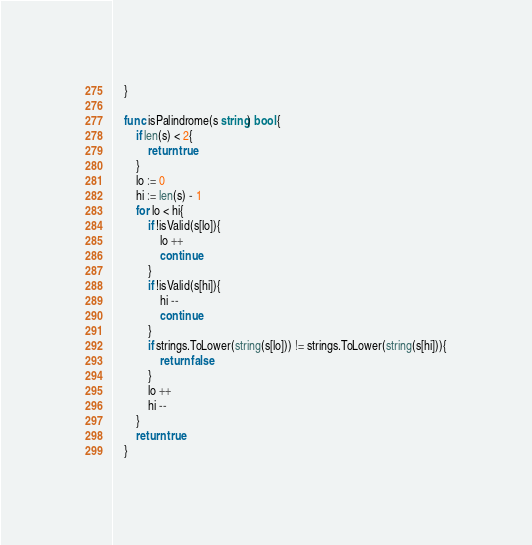<code> <loc_0><loc_0><loc_500><loc_500><_Go_>	}
	
	func isPalindrome(s string) bool {
		if len(s) < 2{
			return true
		}
		lo := 0
		hi := len(s) - 1
		for lo < hi{
			if !isValid(s[lo]){
				lo ++
				continue
			}
			if !isValid(s[hi]){
				hi --
				continue
			}
			if strings.ToLower(string(s[lo])) != strings.ToLower(string(s[hi])){
				return false
			}
			lo ++
			hi -- 
		}
		return true
	}</code> 